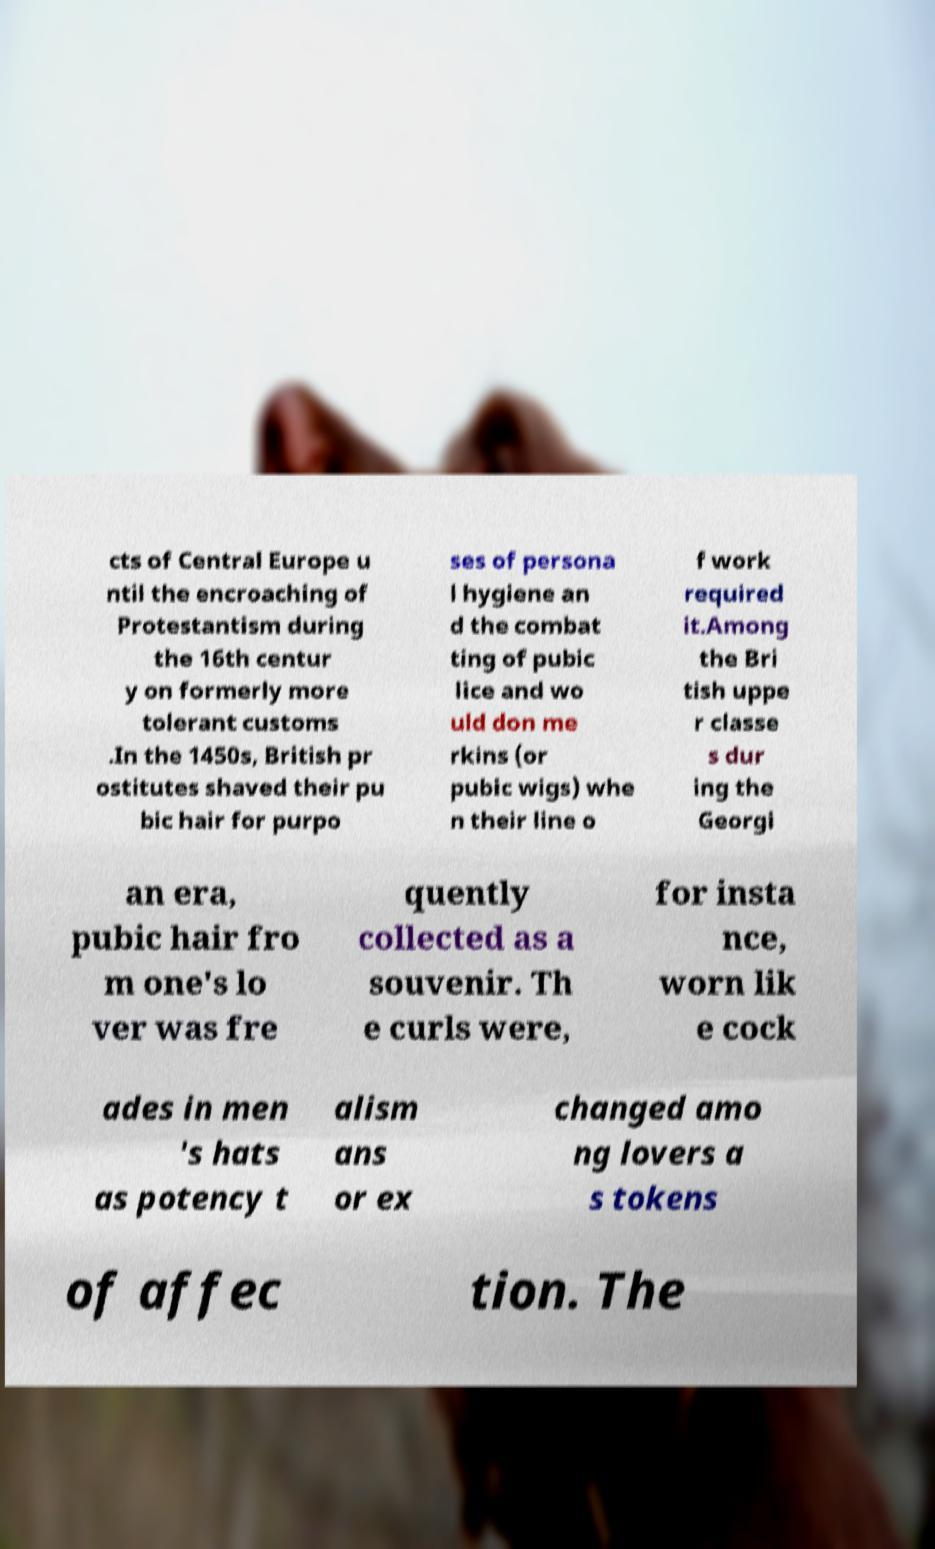There's text embedded in this image that I need extracted. Can you transcribe it verbatim? cts of Central Europe u ntil the encroaching of Protestantism during the 16th centur y on formerly more tolerant customs .In the 1450s, British pr ostitutes shaved their pu bic hair for purpo ses of persona l hygiene an d the combat ting of pubic lice and wo uld don me rkins (or pubic wigs) whe n their line o f work required it.Among the Bri tish uppe r classe s dur ing the Georgi an era, pubic hair fro m one's lo ver was fre quently collected as a souvenir. Th e curls were, for insta nce, worn lik e cock ades in men 's hats as potency t alism ans or ex changed amo ng lovers a s tokens of affec tion. The 